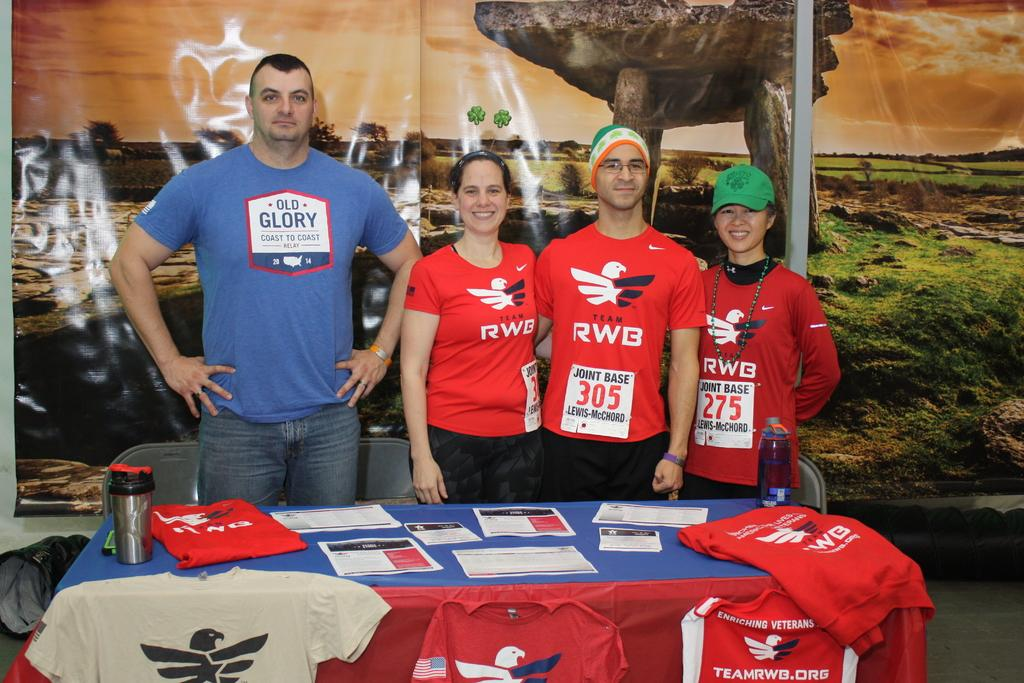<image>
Provide a brief description of the given image. man in blue old glory shirt next to 3 others in team RWB shirts 